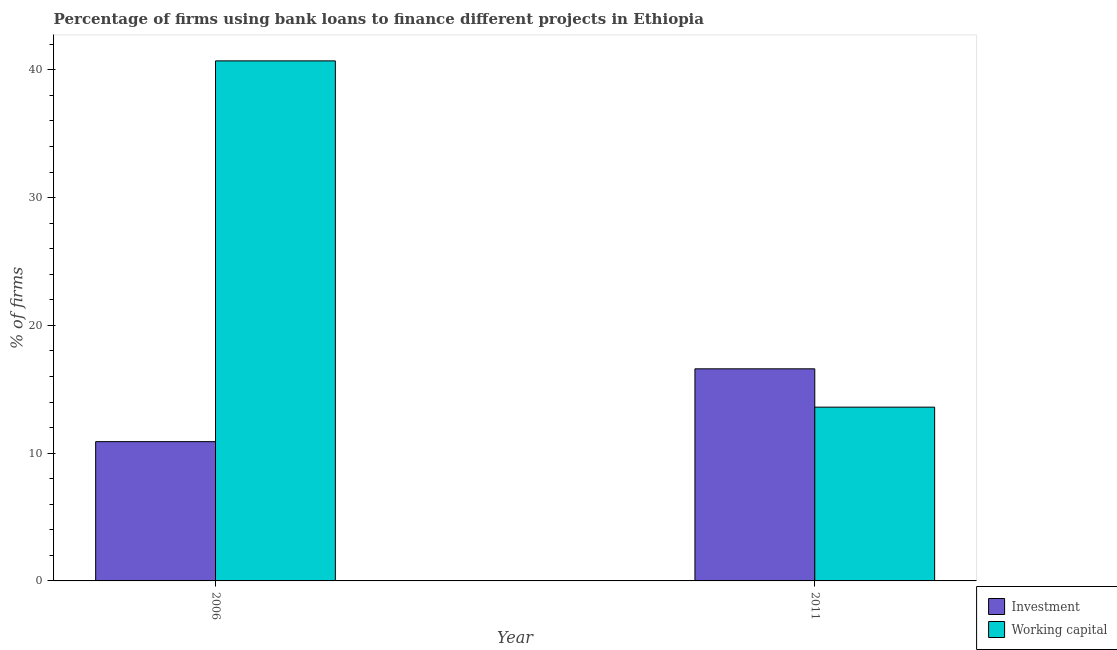How many different coloured bars are there?
Offer a very short reply. 2. How many groups of bars are there?
Provide a succinct answer. 2. How many bars are there on the 1st tick from the right?
Your answer should be compact. 2. In how many cases, is the number of bars for a given year not equal to the number of legend labels?
Make the answer very short. 0. In which year was the percentage of firms using banks to finance working capital minimum?
Offer a very short reply. 2011. What is the total percentage of firms using banks to finance investment in the graph?
Provide a short and direct response. 27.5. What is the difference between the percentage of firms using banks to finance investment in 2006 and that in 2011?
Give a very brief answer. -5.7. What is the difference between the percentage of firms using banks to finance investment in 2011 and the percentage of firms using banks to finance working capital in 2006?
Provide a short and direct response. 5.7. What is the average percentage of firms using banks to finance investment per year?
Your answer should be compact. 13.75. In the year 2006, what is the difference between the percentage of firms using banks to finance working capital and percentage of firms using banks to finance investment?
Offer a terse response. 0. In how many years, is the percentage of firms using banks to finance investment greater than 38 %?
Provide a short and direct response. 0. What is the ratio of the percentage of firms using banks to finance working capital in 2006 to that in 2011?
Keep it short and to the point. 2.99. In how many years, is the percentage of firms using banks to finance investment greater than the average percentage of firms using banks to finance investment taken over all years?
Offer a very short reply. 1. What does the 1st bar from the left in 2011 represents?
Keep it short and to the point. Investment. What does the 2nd bar from the right in 2006 represents?
Your response must be concise. Investment. How many bars are there?
Your response must be concise. 4. Are all the bars in the graph horizontal?
Offer a very short reply. No. How many years are there in the graph?
Provide a short and direct response. 2. What is the difference between two consecutive major ticks on the Y-axis?
Offer a very short reply. 10. Does the graph contain any zero values?
Offer a very short reply. No. Does the graph contain grids?
Your answer should be compact. No. Where does the legend appear in the graph?
Make the answer very short. Bottom right. How many legend labels are there?
Provide a succinct answer. 2. How are the legend labels stacked?
Make the answer very short. Vertical. What is the title of the graph?
Provide a succinct answer. Percentage of firms using bank loans to finance different projects in Ethiopia. Does "Short-term debt" appear as one of the legend labels in the graph?
Ensure brevity in your answer.  No. What is the label or title of the Y-axis?
Offer a terse response. % of firms. What is the % of firms of Working capital in 2006?
Your response must be concise. 40.7. What is the % of firms of Working capital in 2011?
Offer a very short reply. 13.6. Across all years, what is the maximum % of firms in Investment?
Your response must be concise. 16.6. Across all years, what is the maximum % of firms of Working capital?
Give a very brief answer. 40.7. Across all years, what is the minimum % of firms in Working capital?
Offer a very short reply. 13.6. What is the total % of firms in Investment in the graph?
Offer a very short reply. 27.5. What is the total % of firms of Working capital in the graph?
Your answer should be very brief. 54.3. What is the difference between the % of firms in Working capital in 2006 and that in 2011?
Ensure brevity in your answer.  27.1. What is the average % of firms in Investment per year?
Offer a very short reply. 13.75. What is the average % of firms of Working capital per year?
Provide a succinct answer. 27.15. In the year 2006, what is the difference between the % of firms in Investment and % of firms in Working capital?
Give a very brief answer. -29.8. In the year 2011, what is the difference between the % of firms of Investment and % of firms of Working capital?
Keep it short and to the point. 3. What is the ratio of the % of firms of Investment in 2006 to that in 2011?
Your answer should be compact. 0.66. What is the ratio of the % of firms in Working capital in 2006 to that in 2011?
Offer a very short reply. 2.99. What is the difference between the highest and the second highest % of firms in Working capital?
Offer a very short reply. 27.1. What is the difference between the highest and the lowest % of firms of Working capital?
Provide a short and direct response. 27.1. 